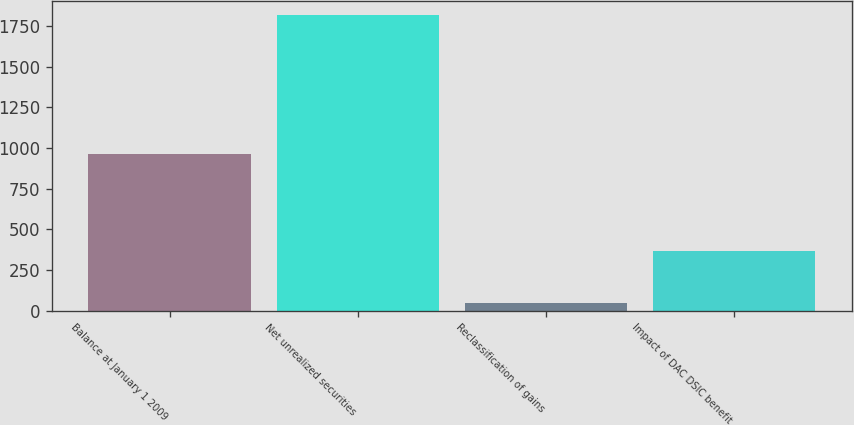Convert chart. <chart><loc_0><loc_0><loc_500><loc_500><bar_chart><fcel>Balance at January 1 2009<fcel>Net unrealized securities<fcel>Reclassification of gains<fcel>Impact of DAC DSIC benefit<nl><fcel>961<fcel>1815<fcel>45<fcel>367<nl></chart> 